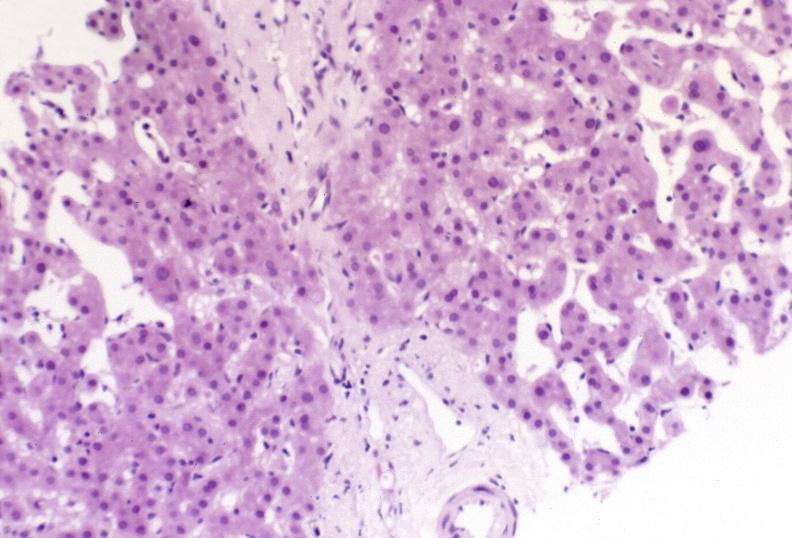what does this image show?
Answer the question using a single word or phrase. Ductopenia 